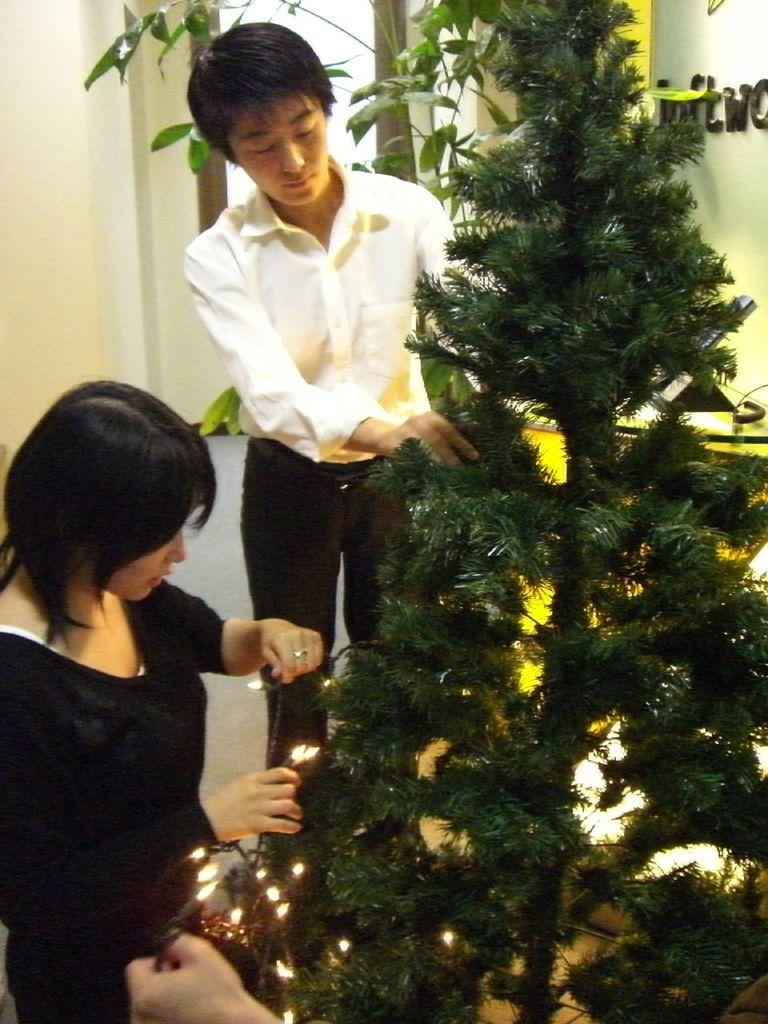Who is present in the image? There are people in the image. What are the people doing in the image? The people are decorating a Christmas tree. Can you describe the actions of one of the individuals in the image? One person is holding lights in her hands. What type of mist can be seen surrounding the Christmas tree in the image? There is no mist present in the image; it features people decorating a Christmas tree. What kind of brass instrument is being played by one of the individuals in the image? There is no brass instrument or any musical instrument being played in the image; the people are decorating a Christmas tree. 